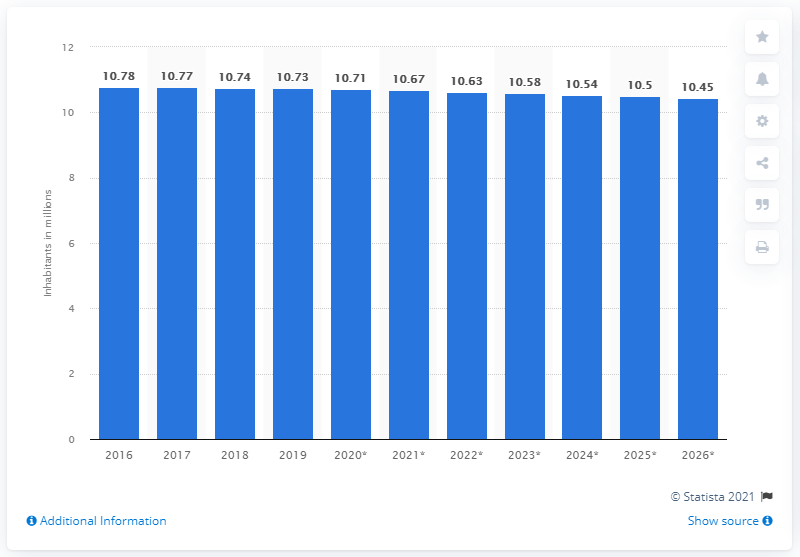Indicate a few pertinent items in this graphic. In 2019, the population of Greece was 10.63 million. 